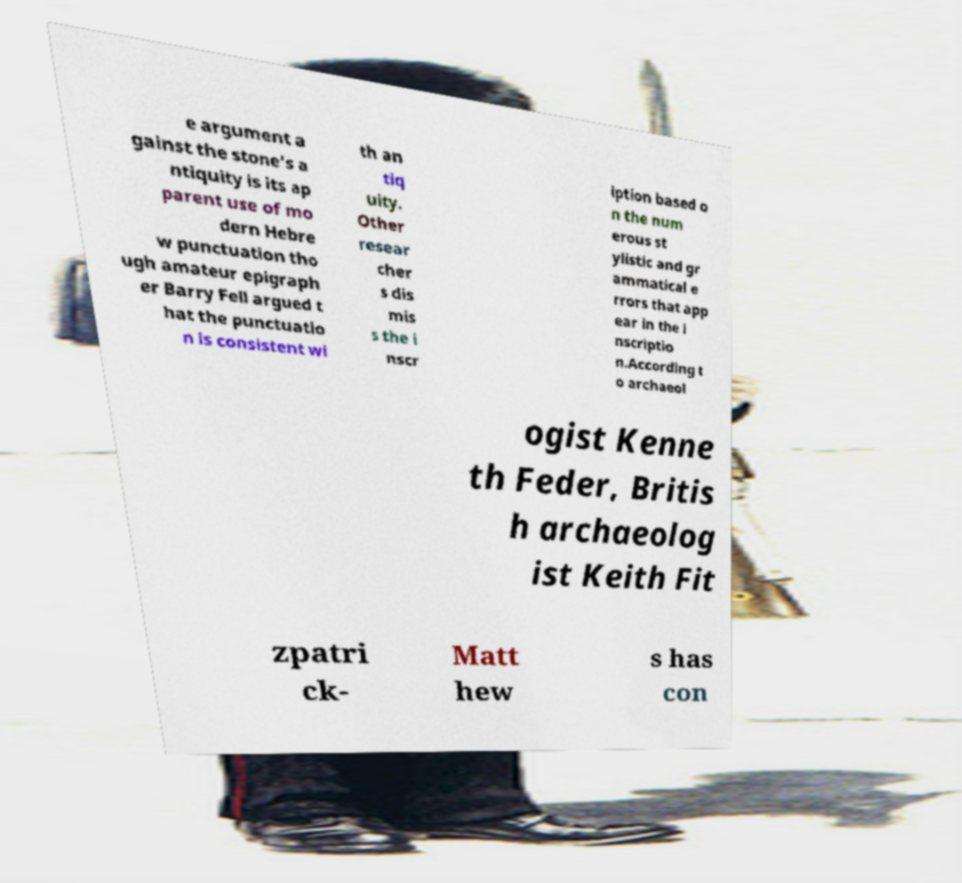What messages or text are displayed in this image? I need them in a readable, typed format. e argument a gainst the stone's a ntiquity is its ap parent use of mo dern Hebre w punctuation tho ugh amateur epigraph er Barry Fell argued t hat the punctuatio n is consistent wi th an tiq uity. Other resear cher s dis mis s the i nscr iption based o n the num erous st ylistic and gr ammatical e rrors that app ear in the i nscriptio n.According t o archaeol ogist Kenne th Feder, Britis h archaeolog ist Keith Fit zpatri ck- Matt hew s has con 